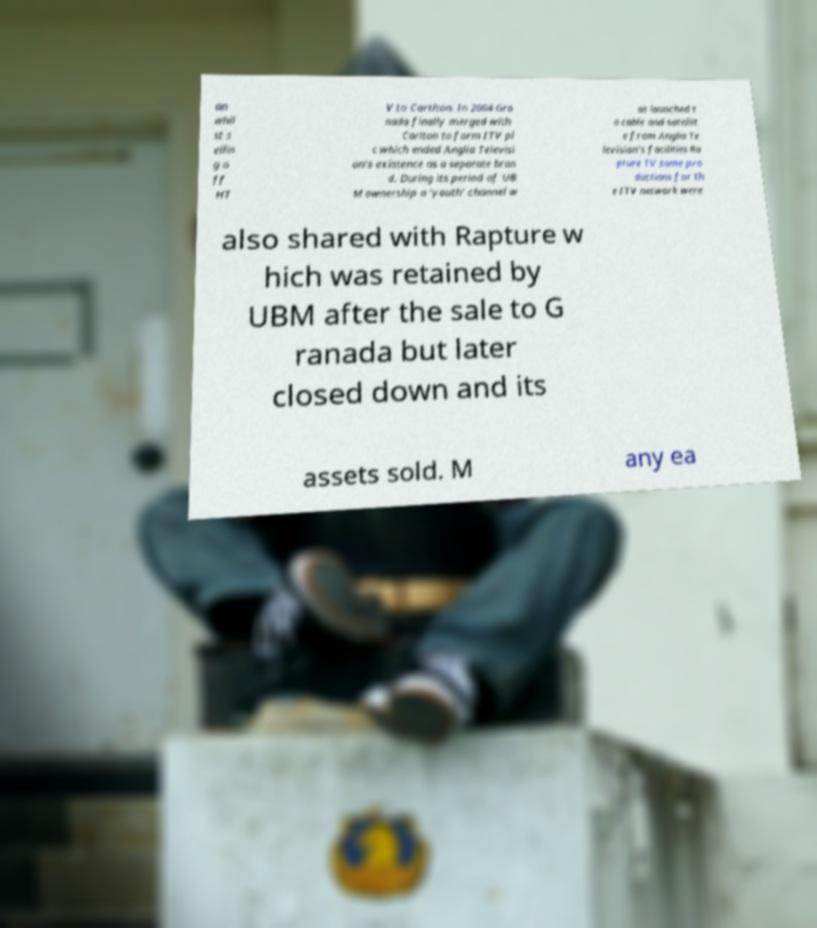Can you read and provide the text displayed in the image?This photo seems to have some interesting text. Can you extract and type it out for me? an whil st s ellin g o ff HT V to Cartlton. In 2004 Gra nada finally merged with Carlton to form ITV pl c which ended Anglia Televisi on's existence as a separate bran d. During its period of UB M ownership a 'youth' channel w as launched t o cable and satellit e from Anglia Te levision's facilities Ra pture TV some pro ductions for th e ITV network were also shared with Rapture w hich was retained by UBM after the sale to G ranada but later closed down and its assets sold. M any ea 